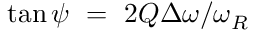Convert formula to latex. <formula><loc_0><loc_0><loc_500><loc_500>\tan { \psi } = 2 Q \Delta \omega / \omega _ { R }</formula> 